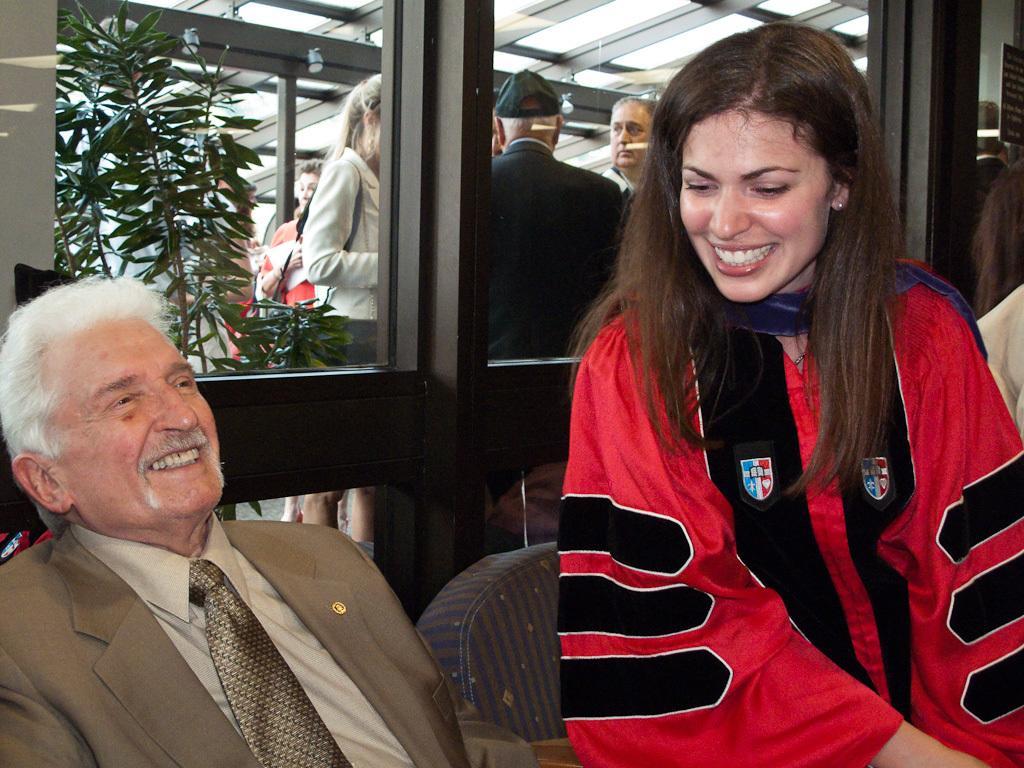In one or two sentences, can you explain what this image depicts? This image is taken indoors. On the left side of the image a man is sitting on the chair and he is with a smiling face. On the right side of the image there is a girl with a smiling face and there is an empty chair. In the background there is a glass door and through the door, we can see there are a few people standing and there is a plant with green leaves. 